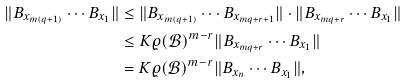Convert formula to latex. <formula><loc_0><loc_0><loc_500><loc_500>\| B _ { x _ { m ( q + 1 ) } } \cdots B _ { x _ { 1 } } \| & \leq \| B _ { x _ { m ( q + 1 ) } } \cdots B _ { x _ { m q + r + 1 } } \| \cdot \| B _ { x _ { m q + r } } \cdots B _ { x _ { 1 } } \| \\ & \leq K \varrho ( \mathcal { B } ) ^ { m - r } \| B _ { x _ { m q + r } } \cdots B _ { x _ { 1 } } \| \\ & = K \varrho ( \mathcal { B } ) ^ { m - r } \| B _ { x _ { n } } \cdots B _ { x _ { 1 } } \| ,</formula> 